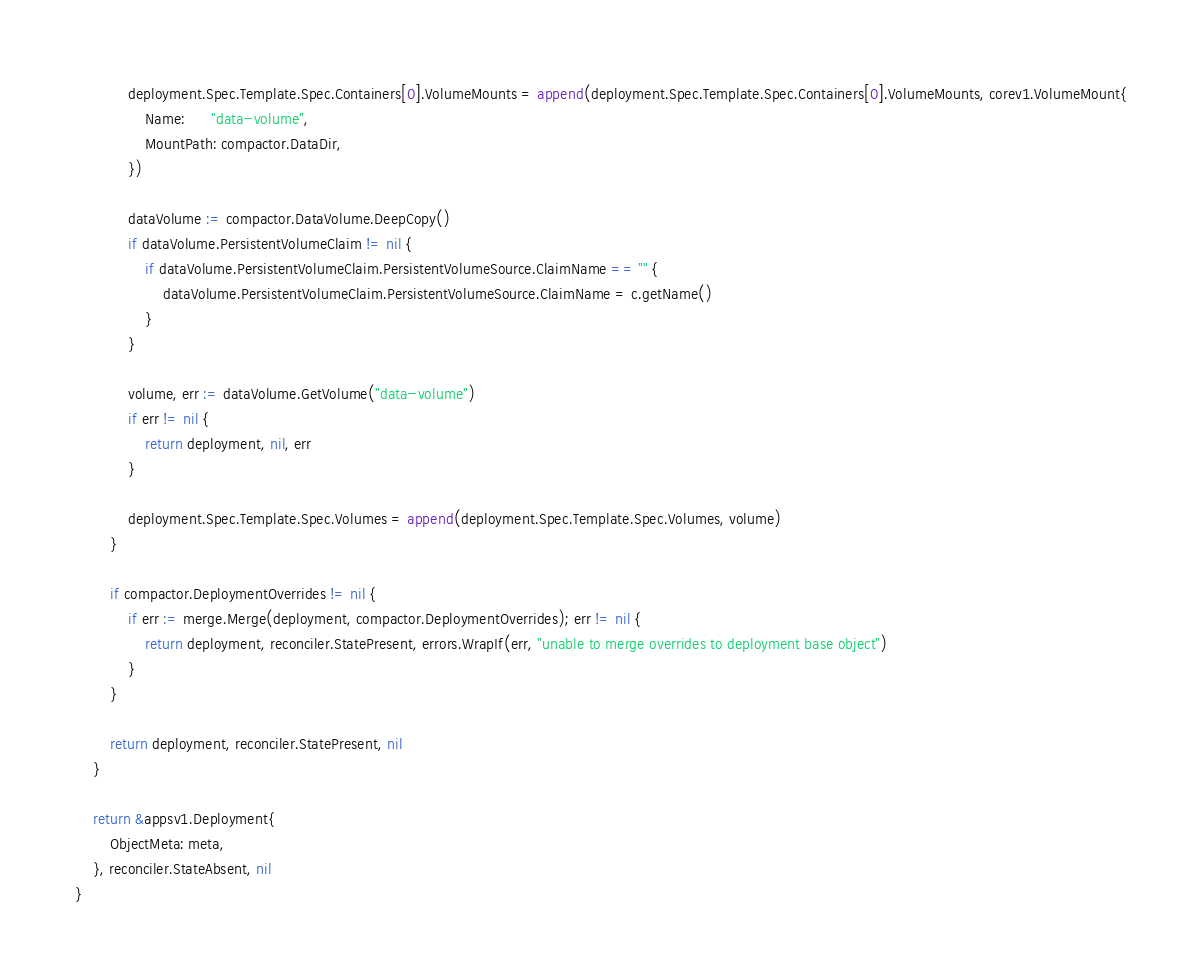Convert code to text. <code><loc_0><loc_0><loc_500><loc_500><_Go_>			deployment.Spec.Template.Spec.Containers[0].VolumeMounts = append(deployment.Spec.Template.Spec.Containers[0].VolumeMounts, corev1.VolumeMount{
				Name:      "data-volume",
				MountPath: compactor.DataDir,
			})

			dataVolume := compactor.DataVolume.DeepCopy()
			if dataVolume.PersistentVolumeClaim != nil {
				if dataVolume.PersistentVolumeClaim.PersistentVolumeSource.ClaimName == "" {
					dataVolume.PersistentVolumeClaim.PersistentVolumeSource.ClaimName = c.getName()
				}
			}

			volume, err := dataVolume.GetVolume("data-volume")
			if err != nil {
				return deployment, nil, err
			}

			deployment.Spec.Template.Spec.Volumes = append(deployment.Spec.Template.Spec.Volumes, volume)
		}

		if compactor.DeploymentOverrides != nil {
			if err := merge.Merge(deployment, compactor.DeploymentOverrides); err != nil {
				return deployment, reconciler.StatePresent, errors.WrapIf(err, "unable to merge overrides to deployment base object")
			}
		}

		return deployment, reconciler.StatePresent, nil
	}

	return &appsv1.Deployment{
		ObjectMeta: meta,
	}, reconciler.StateAbsent, nil
}
</code> 